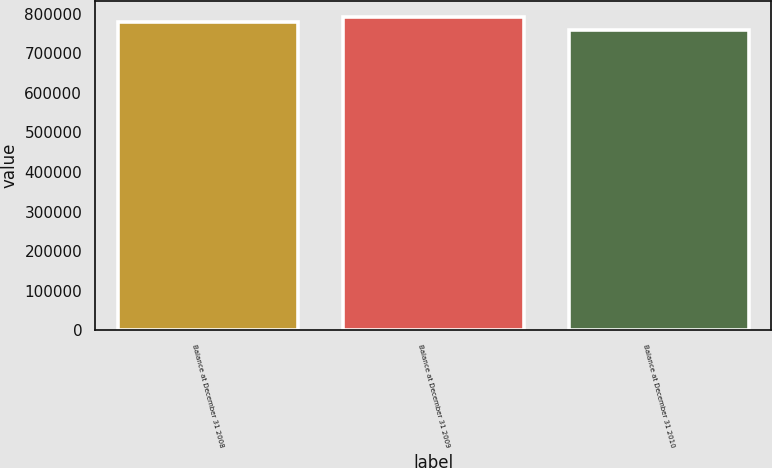<chart> <loc_0><loc_0><loc_500><loc_500><bar_chart><fcel>Balance at December 31 2008<fcel>Balance at December 31 2009<fcel>Balance at December 31 2010<nl><fcel>779246<fcel>792373<fcel>759328<nl></chart> 